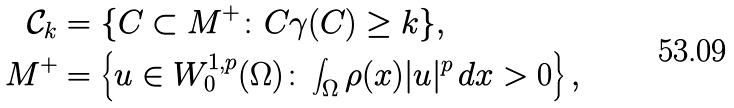<formula> <loc_0><loc_0><loc_500><loc_500>\mathcal { C } _ { k } & = \{ C \subset M ^ { + } \colon C \gamma ( C ) \geq k \} , \\ M ^ { + } & = \left \{ u \in W ^ { 1 , p } _ { 0 } ( \Omega ) \colon \int _ { \Omega } \rho ( x ) | u | ^ { p } \, d x > 0 \right \} ,</formula> 